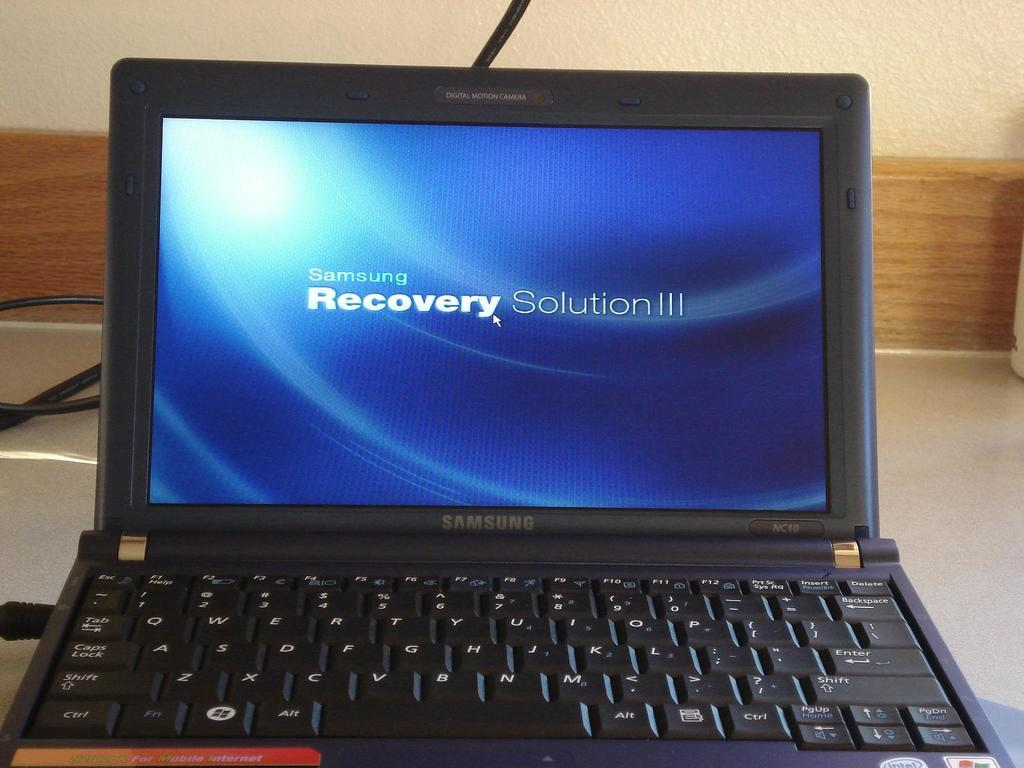<image>
Summarize the visual content of the image. A Samsung laptop computer displays the Samsung Recovery Solution III opening screen. 